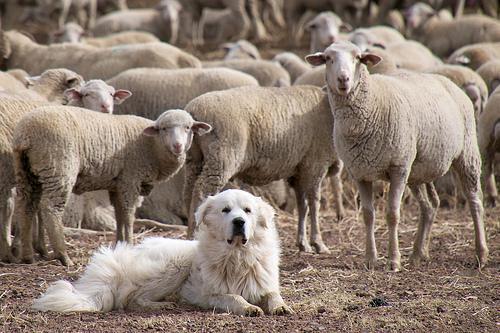How many dogs are there?
Give a very brief answer. 1. How many white dogs are lying down in front of a flock of sheep?
Give a very brief answer. 1. 